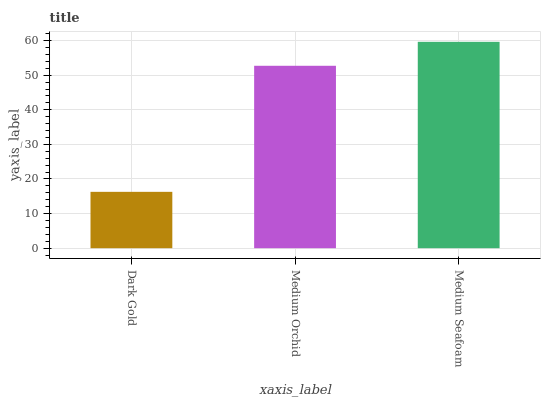Is Dark Gold the minimum?
Answer yes or no. Yes. Is Medium Seafoam the maximum?
Answer yes or no. Yes. Is Medium Orchid the minimum?
Answer yes or no. No. Is Medium Orchid the maximum?
Answer yes or no. No. Is Medium Orchid greater than Dark Gold?
Answer yes or no. Yes. Is Dark Gold less than Medium Orchid?
Answer yes or no. Yes. Is Dark Gold greater than Medium Orchid?
Answer yes or no. No. Is Medium Orchid less than Dark Gold?
Answer yes or no. No. Is Medium Orchid the high median?
Answer yes or no. Yes. Is Medium Orchid the low median?
Answer yes or no. Yes. Is Dark Gold the high median?
Answer yes or no. No. Is Dark Gold the low median?
Answer yes or no. No. 